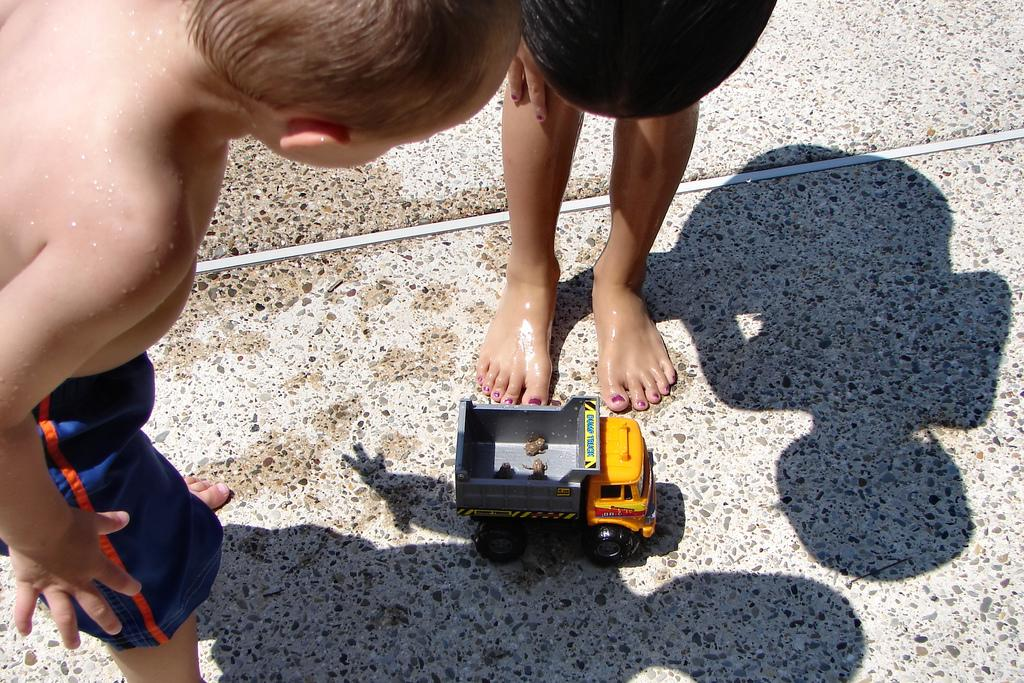What type of toy is present in the image? There is a toy in the image, and it has frogs on it. What is the setting of the image? There is water visible in the image. How many children are in the image, and where are they located? Two children are standing on the left side of the image. What are the children doing in the image? The children are looking at the frogs on the toy. What type of pen is being used to draw on the frogs in the image? There is no pen or drawing activity present in the image; the children are simply looking at the frogs on the toy. 